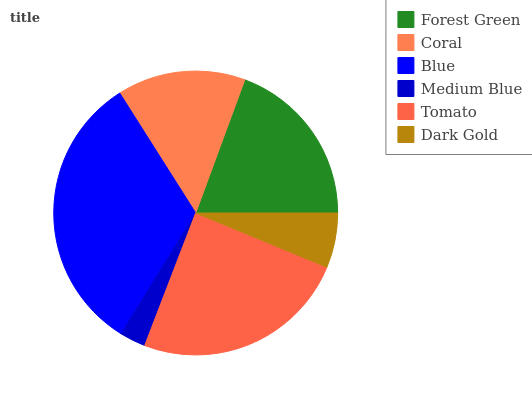Is Medium Blue the minimum?
Answer yes or no. Yes. Is Blue the maximum?
Answer yes or no. Yes. Is Coral the minimum?
Answer yes or no. No. Is Coral the maximum?
Answer yes or no. No. Is Forest Green greater than Coral?
Answer yes or no. Yes. Is Coral less than Forest Green?
Answer yes or no. Yes. Is Coral greater than Forest Green?
Answer yes or no. No. Is Forest Green less than Coral?
Answer yes or no. No. Is Forest Green the high median?
Answer yes or no. Yes. Is Coral the low median?
Answer yes or no. Yes. Is Tomato the high median?
Answer yes or no. No. Is Dark Gold the low median?
Answer yes or no. No. 